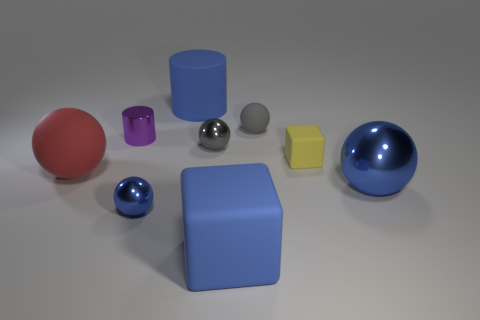Subtract all large blue spheres. How many spheres are left? 4 Subtract all red cylinders. How many gray balls are left? 2 Subtract all blue cylinders. How many cylinders are left? 1 Subtract all spheres. How many objects are left? 4 Add 1 big yellow blocks. How many objects exist? 10 Subtract 1 red spheres. How many objects are left? 8 Subtract 2 cylinders. How many cylinders are left? 0 Subtract all gray cubes. Subtract all gray spheres. How many cubes are left? 2 Subtract all purple cylinders. Subtract all blue matte blocks. How many objects are left? 7 Add 7 large blue shiny spheres. How many large blue shiny spheres are left? 8 